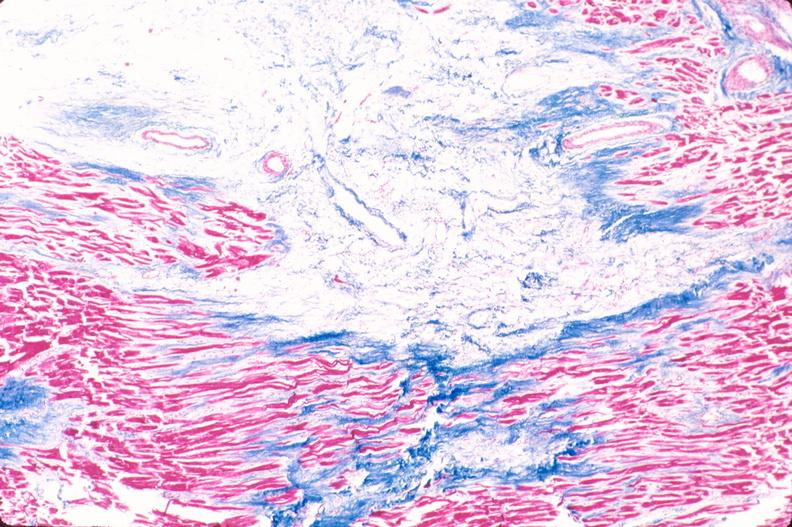s cardiovascular present?
Answer the question using a single word or phrase. Yes 